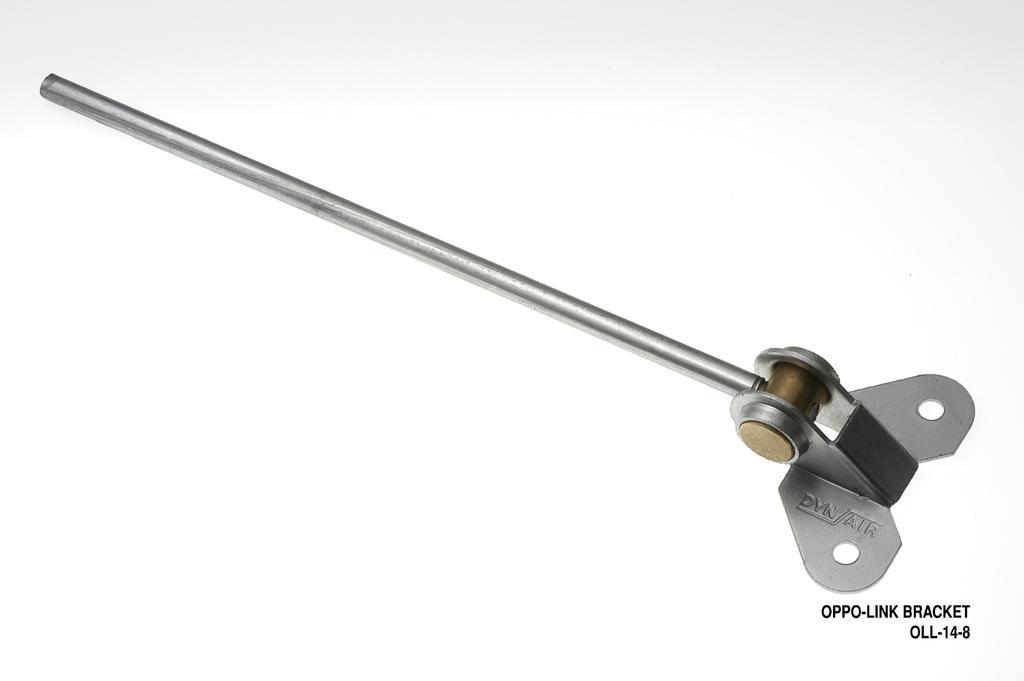Can you describe this image briefly? The picture consists a tool. On the right there is some text. The surface is white. 